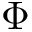Convert formula to latex. <formula><loc_0><loc_0><loc_500><loc_500>\Phi</formula> 